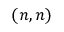Convert formula to latex. <formula><loc_0><loc_0><loc_500><loc_500>( n , n )</formula> 